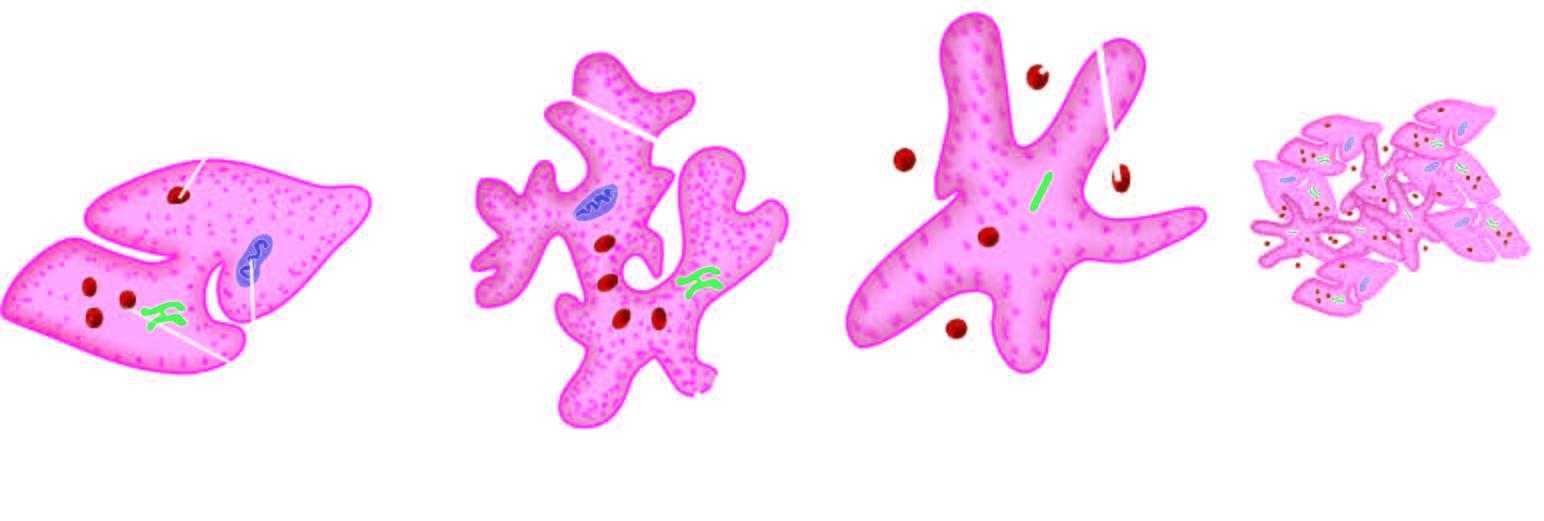does platelet aggregation form a tight plug?
Answer the question using a single word or phrase. Yes 